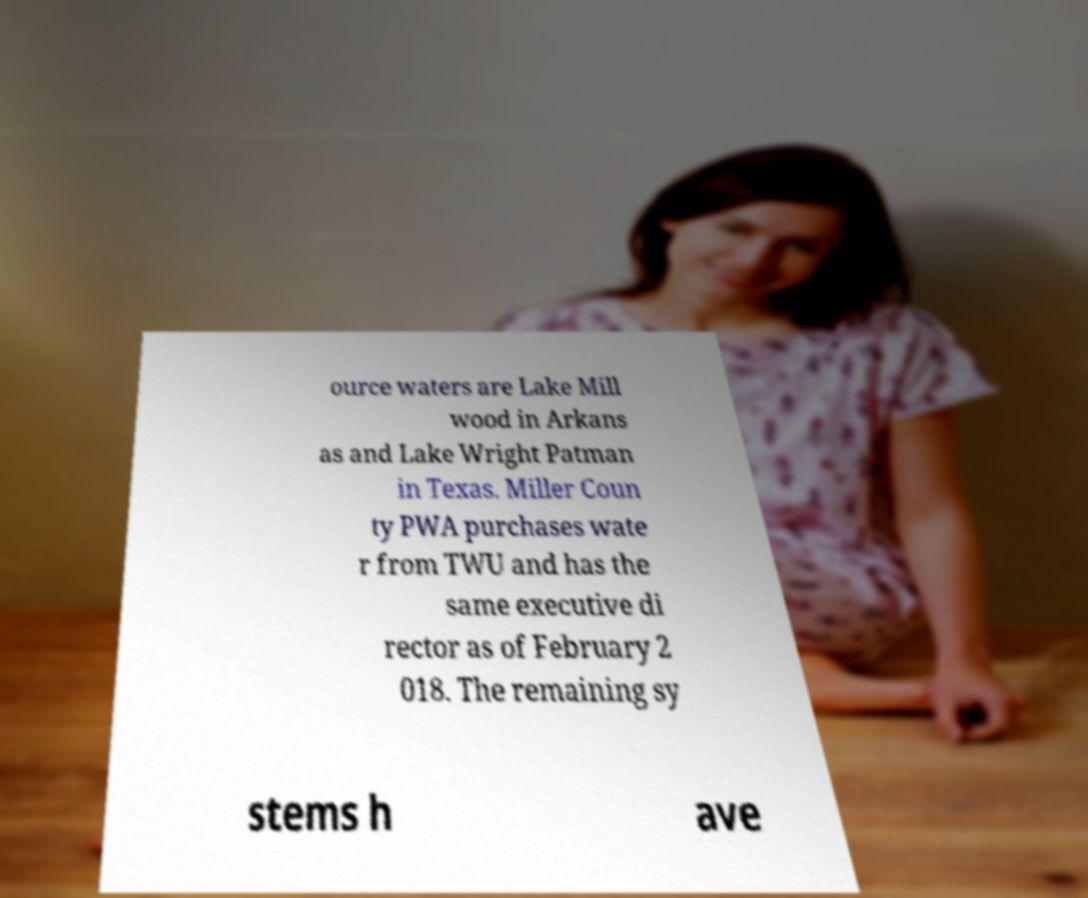Please identify and transcribe the text found in this image. ource waters are Lake Mill wood in Arkans as and Lake Wright Patman in Texas. Miller Coun ty PWA purchases wate r from TWU and has the same executive di rector as of February 2 018. The remaining sy stems h ave 